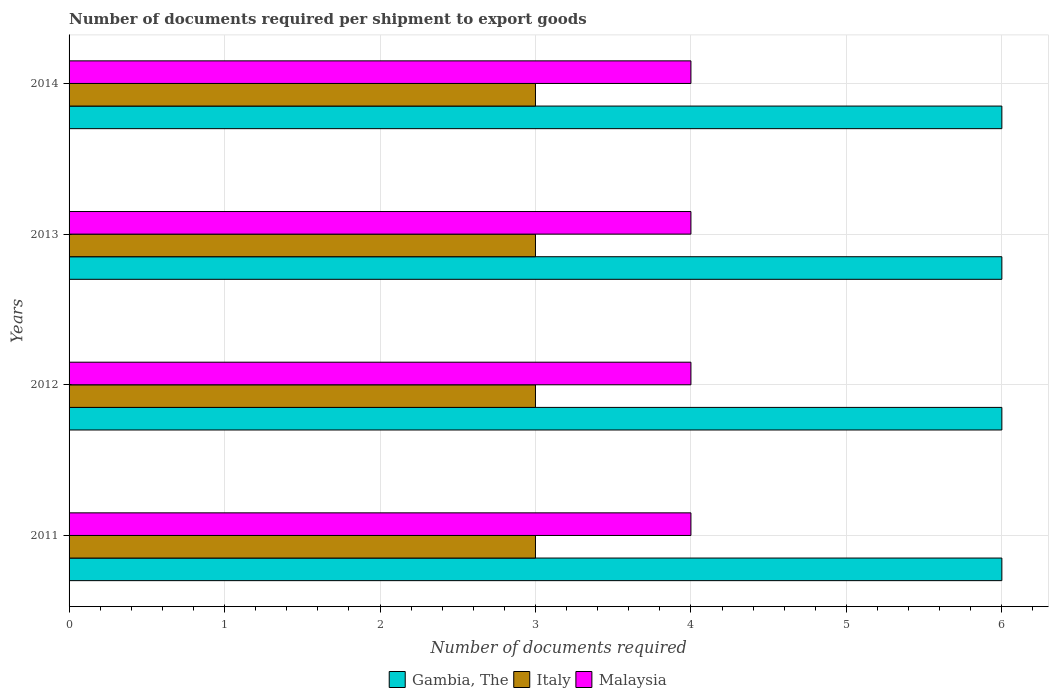How many different coloured bars are there?
Your answer should be very brief. 3. Are the number of bars per tick equal to the number of legend labels?
Your response must be concise. Yes. How many bars are there on the 1st tick from the bottom?
Your answer should be very brief. 3. What is the label of the 4th group of bars from the top?
Offer a very short reply. 2011. In how many cases, is the number of bars for a given year not equal to the number of legend labels?
Ensure brevity in your answer.  0. What is the total number of documents required per shipment to export goods in Malaysia in the graph?
Provide a succinct answer. 16. What is the difference between the number of documents required per shipment to export goods in Malaysia in 2011 and that in 2014?
Your answer should be very brief. 0. What is the difference between the number of documents required per shipment to export goods in Gambia, The in 2013 and the number of documents required per shipment to export goods in Italy in 2012?
Give a very brief answer. 3. What is the average number of documents required per shipment to export goods in Malaysia per year?
Your response must be concise. 4. In the year 2014, what is the difference between the number of documents required per shipment to export goods in Italy and number of documents required per shipment to export goods in Gambia, The?
Provide a succinct answer. -3. In how many years, is the number of documents required per shipment to export goods in Gambia, The greater than 4.6 ?
Offer a terse response. 4. Is the difference between the number of documents required per shipment to export goods in Italy in 2013 and 2014 greater than the difference between the number of documents required per shipment to export goods in Gambia, The in 2013 and 2014?
Offer a terse response. No. What is the difference between the highest and the lowest number of documents required per shipment to export goods in Gambia, The?
Your answer should be very brief. 0. In how many years, is the number of documents required per shipment to export goods in Gambia, The greater than the average number of documents required per shipment to export goods in Gambia, The taken over all years?
Offer a terse response. 0. Is the sum of the number of documents required per shipment to export goods in Gambia, The in 2012 and 2014 greater than the maximum number of documents required per shipment to export goods in Italy across all years?
Offer a terse response. Yes. What does the 1st bar from the top in 2013 represents?
Give a very brief answer. Malaysia. What does the 1st bar from the bottom in 2014 represents?
Provide a succinct answer. Gambia, The. Is it the case that in every year, the sum of the number of documents required per shipment to export goods in Italy and number of documents required per shipment to export goods in Malaysia is greater than the number of documents required per shipment to export goods in Gambia, The?
Your response must be concise. Yes. How many bars are there?
Provide a succinct answer. 12. Are all the bars in the graph horizontal?
Provide a succinct answer. Yes. Are the values on the major ticks of X-axis written in scientific E-notation?
Offer a very short reply. No. Where does the legend appear in the graph?
Your answer should be compact. Bottom center. What is the title of the graph?
Offer a very short reply. Number of documents required per shipment to export goods. What is the label or title of the X-axis?
Your answer should be very brief. Number of documents required. What is the Number of documents required in Gambia, The in 2012?
Your response must be concise. 6. What is the Number of documents required in Italy in 2012?
Your answer should be compact. 3. What is the Number of documents required in Malaysia in 2012?
Your response must be concise. 4. What is the Number of documents required in Gambia, The in 2013?
Your answer should be compact. 6. What is the Number of documents required in Malaysia in 2013?
Your answer should be very brief. 4. What is the Number of documents required of Malaysia in 2014?
Offer a terse response. 4. Across all years, what is the maximum Number of documents required of Italy?
Make the answer very short. 3. Across all years, what is the maximum Number of documents required of Malaysia?
Provide a succinct answer. 4. Across all years, what is the minimum Number of documents required in Italy?
Offer a terse response. 3. Across all years, what is the minimum Number of documents required in Malaysia?
Provide a succinct answer. 4. What is the difference between the Number of documents required in Gambia, The in 2011 and that in 2012?
Offer a very short reply. 0. What is the difference between the Number of documents required in Malaysia in 2011 and that in 2012?
Your answer should be compact. 0. What is the difference between the Number of documents required in Gambia, The in 2011 and that in 2013?
Ensure brevity in your answer.  0. What is the difference between the Number of documents required in Italy in 2011 and that in 2014?
Keep it short and to the point. 0. What is the difference between the Number of documents required of Malaysia in 2012 and that in 2014?
Provide a succinct answer. 0. What is the difference between the Number of documents required in Italy in 2013 and that in 2014?
Your response must be concise. 0. What is the difference between the Number of documents required of Gambia, The in 2011 and the Number of documents required of Italy in 2013?
Ensure brevity in your answer.  3. What is the difference between the Number of documents required of Gambia, The in 2011 and the Number of documents required of Malaysia in 2013?
Provide a short and direct response. 2. What is the difference between the Number of documents required in Italy in 2011 and the Number of documents required in Malaysia in 2013?
Your answer should be very brief. -1. What is the difference between the Number of documents required in Gambia, The in 2011 and the Number of documents required in Malaysia in 2014?
Provide a succinct answer. 2. What is the difference between the Number of documents required in Italy in 2011 and the Number of documents required in Malaysia in 2014?
Offer a very short reply. -1. What is the difference between the Number of documents required in Gambia, The in 2012 and the Number of documents required in Italy in 2013?
Provide a short and direct response. 3. What is the difference between the Number of documents required in Gambia, The in 2012 and the Number of documents required in Malaysia in 2013?
Your response must be concise. 2. What is the difference between the Number of documents required of Italy in 2012 and the Number of documents required of Malaysia in 2013?
Provide a short and direct response. -1. What is the difference between the Number of documents required in Gambia, The in 2012 and the Number of documents required in Italy in 2014?
Your response must be concise. 3. What is the difference between the Number of documents required in Gambia, The in 2012 and the Number of documents required in Malaysia in 2014?
Give a very brief answer. 2. What is the difference between the Number of documents required in Italy in 2012 and the Number of documents required in Malaysia in 2014?
Give a very brief answer. -1. What is the difference between the Number of documents required in Gambia, The in 2013 and the Number of documents required in Malaysia in 2014?
Give a very brief answer. 2. What is the average Number of documents required of Italy per year?
Your answer should be compact. 3. In the year 2011, what is the difference between the Number of documents required of Italy and Number of documents required of Malaysia?
Your answer should be very brief. -1. In the year 2012, what is the difference between the Number of documents required in Gambia, The and Number of documents required in Italy?
Your answer should be very brief. 3. In the year 2012, what is the difference between the Number of documents required in Gambia, The and Number of documents required in Malaysia?
Provide a short and direct response. 2. In the year 2012, what is the difference between the Number of documents required in Italy and Number of documents required in Malaysia?
Provide a succinct answer. -1. In the year 2013, what is the difference between the Number of documents required of Italy and Number of documents required of Malaysia?
Offer a very short reply. -1. In the year 2014, what is the difference between the Number of documents required of Gambia, The and Number of documents required of Italy?
Your answer should be compact. 3. In the year 2014, what is the difference between the Number of documents required of Italy and Number of documents required of Malaysia?
Your answer should be very brief. -1. What is the ratio of the Number of documents required in Italy in 2011 to that in 2012?
Provide a succinct answer. 1. What is the ratio of the Number of documents required in Gambia, The in 2011 to that in 2013?
Ensure brevity in your answer.  1. What is the ratio of the Number of documents required of Italy in 2011 to that in 2013?
Ensure brevity in your answer.  1. What is the ratio of the Number of documents required of Malaysia in 2011 to that in 2014?
Ensure brevity in your answer.  1. What is the ratio of the Number of documents required of Gambia, The in 2012 to that in 2013?
Make the answer very short. 1. What is the ratio of the Number of documents required of Gambia, The in 2013 to that in 2014?
Your response must be concise. 1. What is the difference between the highest and the second highest Number of documents required of Gambia, The?
Make the answer very short. 0. What is the difference between the highest and the lowest Number of documents required in Italy?
Make the answer very short. 0. What is the difference between the highest and the lowest Number of documents required of Malaysia?
Offer a terse response. 0. 